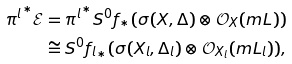Convert formula to latex. <formula><loc_0><loc_0><loc_500><loc_500>{ \pi ^ { l } } ^ { * } \mathcal { E } & = { \pi ^ { l } } ^ { * } S ^ { 0 } f _ { * } ( \sigma ( X , \Delta ) \otimes \mathcal { O } _ { X } ( m L ) ) \\ & \cong S ^ { 0 } { f _ { l } } _ { * } ( \sigma ( X _ { l } , \Delta _ { l } ) \otimes \mathcal { O } _ { X _ { l } } ( m L _ { l } ) ) ,</formula> 